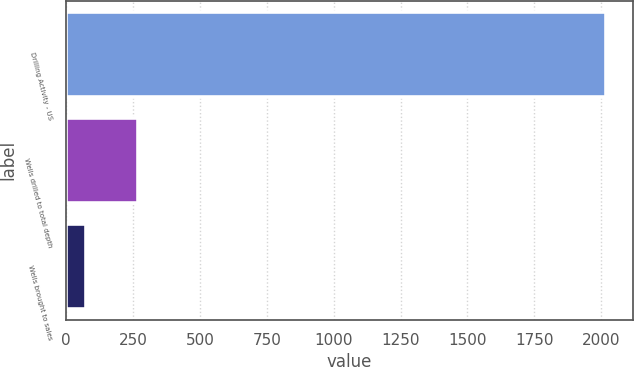Convert chart to OTSL. <chart><loc_0><loc_0><loc_500><loc_500><bar_chart><fcel>Drilling Activity - US<fcel>Wells drilled to total depth<fcel>Wells brought to sales<nl><fcel>2017<fcel>267.4<fcel>73<nl></chart> 